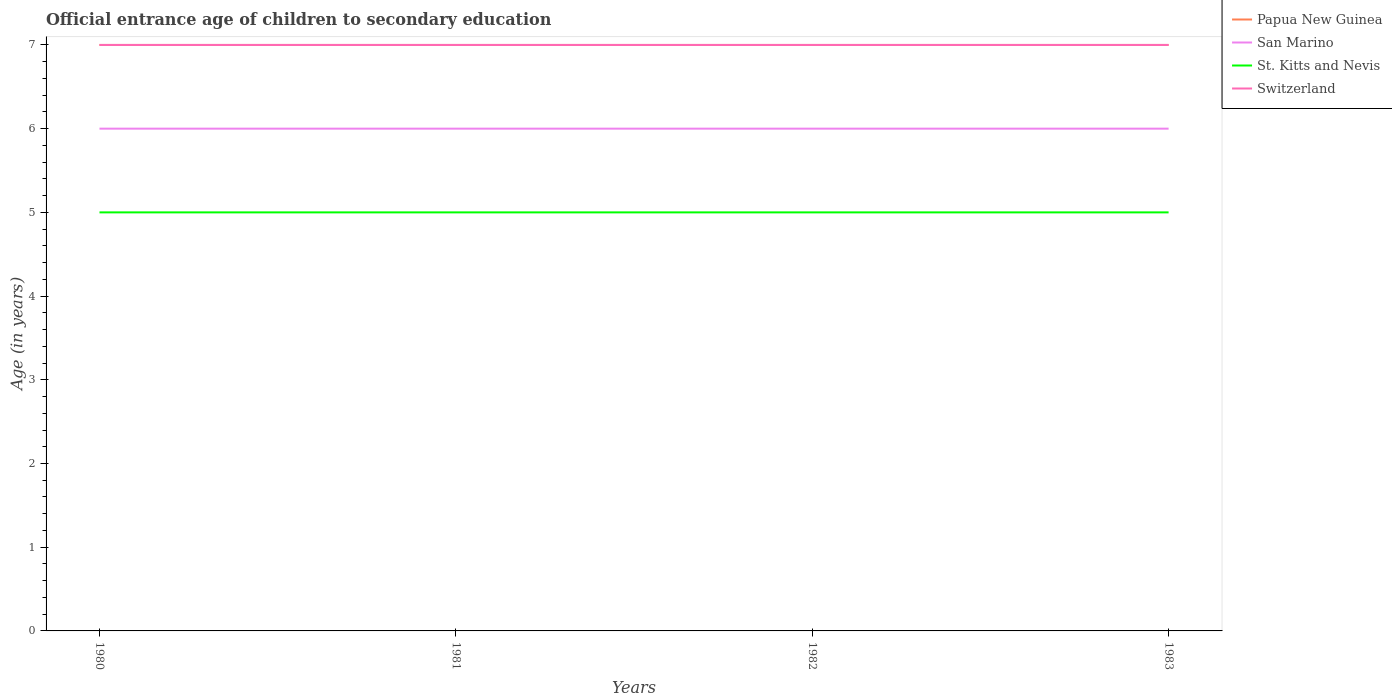How many different coloured lines are there?
Keep it short and to the point. 4. Is the number of lines equal to the number of legend labels?
Provide a succinct answer. Yes. Across all years, what is the maximum secondary school starting age of children in San Marino?
Provide a short and direct response. 6. In which year was the secondary school starting age of children in Papua New Guinea maximum?
Provide a succinct answer. 1980. What is the difference between the highest and the second highest secondary school starting age of children in Switzerland?
Your answer should be compact. 0. What is the difference between the highest and the lowest secondary school starting age of children in St. Kitts and Nevis?
Offer a terse response. 0. How many years are there in the graph?
Ensure brevity in your answer.  4. Are the values on the major ticks of Y-axis written in scientific E-notation?
Make the answer very short. No. Does the graph contain any zero values?
Your response must be concise. No. How many legend labels are there?
Give a very brief answer. 4. What is the title of the graph?
Give a very brief answer. Official entrance age of children to secondary education. What is the label or title of the X-axis?
Ensure brevity in your answer.  Years. What is the label or title of the Y-axis?
Your answer should be compact. Age (in years). What is the Age (in years) of San Marino in 1980?
Offer a terse response. 6. What is the Age (in years) in Switzerland in 1980?
Provide a short and direct response. 7. What is the Age (in years) of San Marino in 1981?
Ensure brevity in your answer.  6. What is the Age (in years) in Switzerland in 1981?
Your response must be concise. 7. What is the Age (in years) in San Marino in 1982?
Give a very brief answer. 6. What is the Age (in years) in St. Kitts and Nevis in 1982?
Provide a short and direct response. 5. What is the Age (in years) of San Marino in 1983?
Provide a succinct answer. 6. What is the Age (in years) in St. Kitts and Nevis in 1983?
Your answer should be compact. 5. What is the Age (in years) of Switzerland in 1983?
Provide a short and direct response. 7. Across all years, what is the maximum Age (in years) of Papua New Guinea?
Your response must be concise. 7. Across all years, what is the maximum Age (in years) in San Marino?
Ensure brevity in your answer.  6. Across all years, what is the maximum Age (in years) in St. Kitts and Nevis?
Offer a terse response. 5. Across all years, what is the maximum Age (in years) of Switzerland?
Your answer should be very brief. 7. Across all years, what is the minimum Age (in years) in Papua New Guinea?
Your answer should be very brief. 7. Across all years, what is the minimum Age (in years) of San Marino?
Provide a succinct answer. 6. Across all years, what is the minimum Age (in years) in St. Kitts and Nevis?
Your answer should be compact. 5. Across all years, what is the minimum Age (in years) in Switzerland?
Offer a terse response. 7. What is the total Age (in years) in Papua New Guinea in the graph?
Provide a short and direct response. 28. What is the total Age (in years) in San Marino in the graph?
Give a very brief answer. 24. What is the total Age (in years) in Switzerland in the graph?
Provide a short and direct response. 28. What is the difference between the Age (in years) of San Marino in 1980 and that in 1982?
Keep it short and to the point. 0. What is the difference between the Age (in years) of Switzerland in 1980 and that in 1982?
Make the answer very short. 0. What is the difference between the Age (in years) of San Marino in 1980 and that in 1983?
Provide a short and direct response. 0. What is the difference between the Age (in years) of St. Kitts and Nevis in 1980 and that in 1983?
Your answer should be very brief. 0. What is the difference between the Age (in years) in Switzerland in 1980 and that in 1983?
Give a very brief answer. 0. What is the difference between the Age (in years) of Papua New Guinea in 1981 and that in 1982?
Your response must be concise. 0. What is the difference between the Age (in years) of San Marino in 1981 and that in 1982?
Your response must be concise. 0. What is the difference between the Age (in years) of Switzerland in 1981 and that in 1982?
Give a very brief answer. 0. What is the difference between the Age (in years) in St. Kitts and Nevis in 1981 and that in 1983?
Offer a terse response. 0. What is the difference between the Age (in years) in Papua New Guinea in 1982 and that in 1983?
Keep it short and to the point. 0. What is the difference between the Age (in years) in St. Kitts and Nevis in 1982 and that in 1983?
Offer a very short reply. 0. What is the difference between the Age (in years) in Papua New Guinea in 1980 and the Age (in years) in San Marino in 1981?
Your answer should be very brief. 1. What is the difference between the Age (in years) in San Marino in 1980 and the Age (in years) in Switzerland in 1981?
Ensure brevity in your answer.  -1. What is the difference between the Age (in years) in St. Kitts and Nevis in 1980 and the Age (in years) in Switzerland in 1981?
Keep it short and to the point. -2. What is the difference between the Age (in years) in Papua New Guinea in 1980 and the Age (in years) in St. Kitts and Nevis in 1982?
Offer a very short reply. 2. What is the difference between the Age (in years) in San Marino in 1980 and the Age (in years) in Switzerland in 1982?
Offer a very short reply. -1. What is the difference between the Age (in years) of St. Kitts and Nevis in 1980 and the Age (in years) of Switzerland in 1982?
Your answer should be compact. -2. What is the difference between the Age (in years) in Papua New Guinea in 1980 and the Age (in years) in San Marino in 1983?
Offer a terse response. 1. What is the difference between the Age (in years) of Papua New Guinea in 1980 and the Age (in years) of St. Kitts and Nevis in 1983?
Your answer should be very brief. 2. What is the difference between the Age (in years) in Papua New Guinea in 1980 and the Age (in years) in Switzerland in 1983?
Provide a succinct answer. 0. What is the difference between the Age (in years) of San Marino in 1980 and the Age (in years) of Switzerland in 1983?
Ensure brevity in your answer.  -1. What is the difference between the Age (in years) of Papua New Guinea in 1981 and the Age (in years) of Switzerland in 1982?
Your answer should be compact. 0. What is the difference between the Age (in years) in San Marino in 1981 and the Age (in years) in St. Kitts and Nevis in 1982?
Your answer should be very brief. 1. What is the difference between the Age (in years) of San Marino in 1981 and the Age (in years) of Switzerland in 1982?
Offer a terse response. -1. What is the difference between the Age (in years) in Papua New Guinea in 1981 and the Age (in years) in San Marino in 1983?
Give a very brief answer. 1. What is the difference between the Age (in years) in St. Kitts and Nevis in 1981 and the Age (in years) in Switzerland in 1983?
Make the answer very short. -2. What is the difference between the Age (in years) of Papua New Guinea in 1982 and the Age (in years) of San Marino in 1983?
Offer a terse response. 1. What is the difference between the Age (in years) of Papua New Guinea in 1982 and the Age (in years) of St. Kitts and Nevis in 1983?
Offer a terse response. 2. What is the difference between the Age (in years) in Papua New Guinea in 1982 and the Age (in years) in Switzerland in 1983?
Provide a succinct answer. 0. What is the difference between the Age (in years) of St. Kitts and Nevis in 1982 and the Age (in years) of Switzerland in 1983?
Offer a very short reply. -2. What is the average Age (in years) in San Marino per year?
Provide a succinct answer. 6. What is the average Age (in years) of St. Kitts and Nevis per year?
Your answer should be very brief. 5. What is the average Age (in years) of Switzerland per year?
Provide a short and direct response. 7. In the year 1980, what is the difference between the Age (in years) of Papua New Guinea and Age (in years) of San Marino?
Offer a very short reply. 1. In the year 1980, what is the difference between the Age (in years) in Papua New Guinea and Age (in years) in St. Kitts and Nevis?
Provide a short and direct response. 2. In the year 1980, what is the difference between the Age (in years) in San Marino and Age (in years) in Switzerland?
Offer a very short reply. -1. In the year 1981, what is the difference between the Age (in years) of San Marino and Age (in years) of Switzerland?
Offer a very short reply. -1. In the year 1981, what is the difference between the Age (in years) in St. Kitts and Nevis and Age (in years) in Switzerland?
Keep it short and to the point. -2. In the year 1982, what is the difference between the Age (in years) in Papua New Guinea and Age (in years) in Switzerland?
Make the answer very short. 0. In the year 1983, what is the difference between the Age (in years) of Papua New Guinea and Age (in years) of San Marino?
Your answer should be very brief. 1. In the year 1983, what is the difference between the Age (in years) in Papua New Guinea and Age (in years) in St. Kitts and Nevis?
Ensure brevity in your answer.  2. In the year 1983, what is the difference between the Age (in years) of Papua New Guinea and Age (in years) of Switzerland?
Offer a terse response. 0. In the year 1983, what is the difference between the Age (in years) of San Marino and Age (in years) of Switzerland?
Keep it short and to the point. -1. In the year 1983, what is the difference between the Age (in years) of St. Kitts and Nevis and Age (in years) of Switzerland?
Make the answer very short. -2. What is the ratio of the Age (in years) of Papua New Guinea in 1980 to that in 1981?
Offer a terse response. 1. What is the ratio of the Age (in years) of Papua New Guinea in 1980 to that in 1982?
Provide a succinct answer. 1. What is the ratio of the Age (in years) in Papua New Guinea in 1980 to that in 1983?
Ensure brevity in your answer.  1. What is the ratio of the Age (in years) in San Marino in 1980 to that in 1983?
Provide a succinct answer. 1. What is the ratio of the Age (in years) of Papua New Guinea in 1981 to that in 1982?
Offer a very short reply. 1. What is the ratio of the Age (in years) in Switzerland in 1981 to that in 1982?
Provide a short and direct response. 1. What is the ratio of the Age (in years) of Papua New Guinea in 1981 to that in 1983?
Make the answer very short. 1. What is the ratio of the Age (in years) in San Marino in 1981 to that in 1983?
Keep it short and to the point. 1. What is the ratio of the Age (in years) in St. Kitts and Nevis in 1981 to that in 1983?
Keep it short and to the point. 1. What is the ratio of the Age (in years) of Switzerland in 1981 to that in 1983?
Provide a short and direct response. 1. What is the ratio of the Age (in years) of Papua New Guinea in 1982 to that in 1983?
Offer a terse response. 1. What is the ratio of the Age (in years) in San Marino in 1982 to that in 1983?
Provide a short and direct response. 1. What is the ratio of the Age (in years) of St. Kitts and Nevis in 1982 to that in 1983?
Provide a short and direct response. 1. What is the difference between the highest and the lowest Age (in years) in San Marino?
Ensure brevity in your answer.  0. What is the difference between the highest and the lowest Age (in years) in Switzerland?
Your response must be concise. 0. 